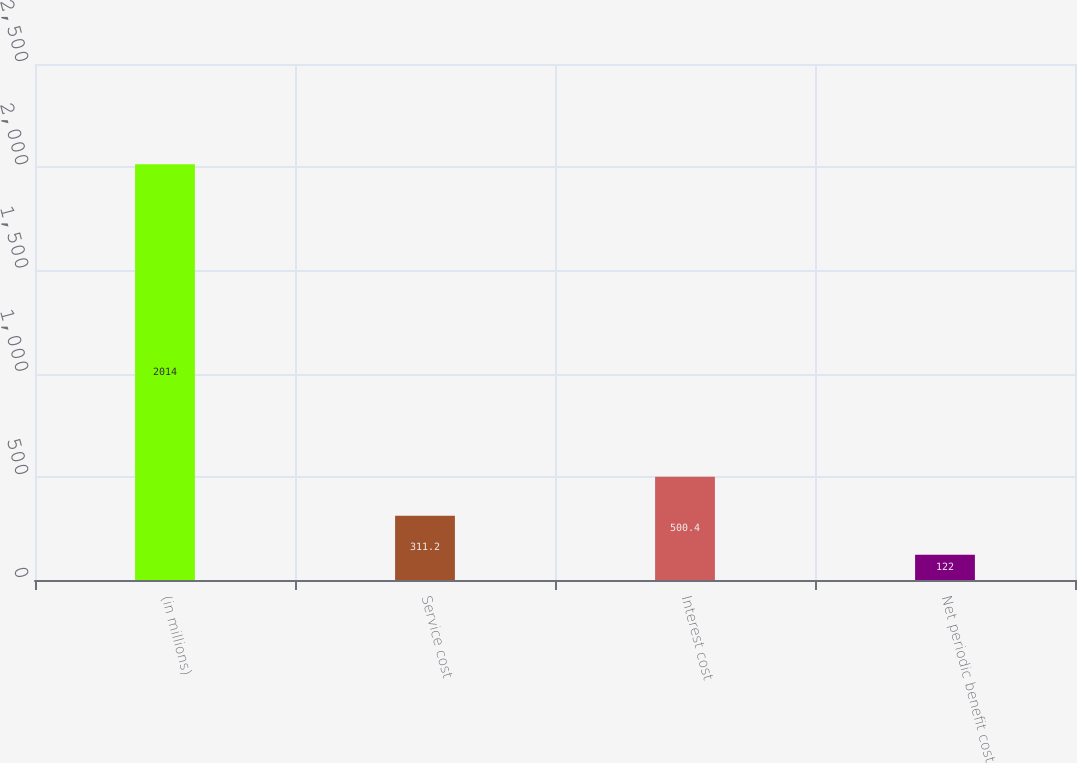Convert chart. <chart><loc_0><loc_0><loc_500><loc_500><bar_chart><fcel>(in millions)<fcel>Service cost<fcel>Interest cost<fcel>Net periodic benefit cost<nl><fcel>2014<fcel>311.2<fcel>500.4<fcel>122<nl></chart> 